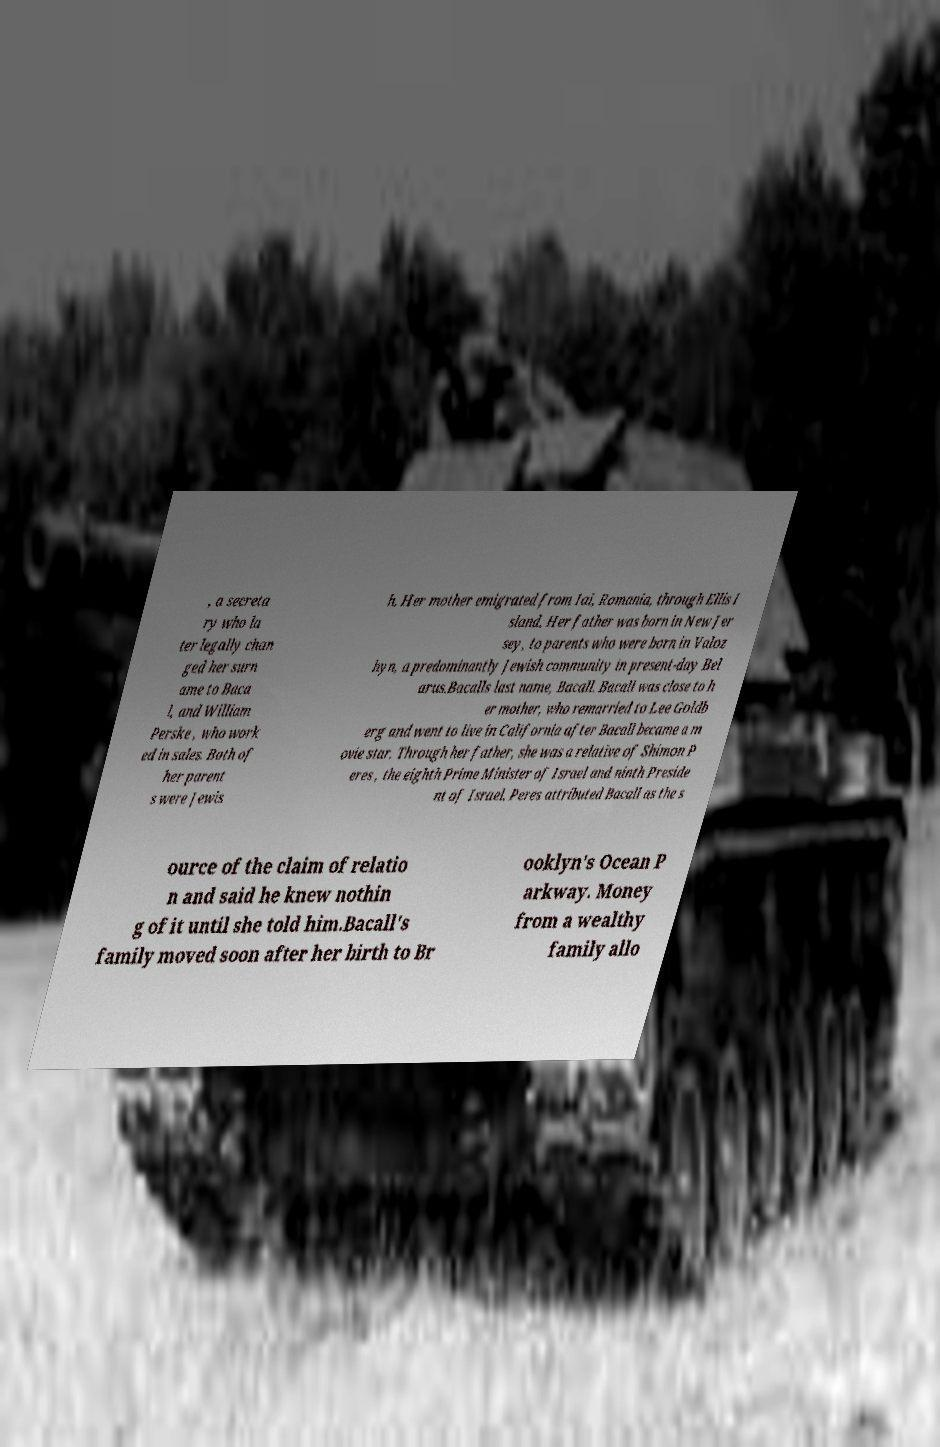Please identify and transcribe the text found in this image. , a secreta ry who la ter legally chan ged her surn ame to Baca l, and William Perske , who work ed in sales. Both of her parent s were Jewis h. Her mother emigrated from Iai, Romania, through Ellis I sland. Her father was born in New Jer sey, to parents who were born in Valoz hyn, a predominantly Jewish community in present-day Bel arus.Bacalls last name, Bacall. Bacall was close to h er mother, who remarried to Lee Goldb erg and went to live in California after Bacall became a m ovie star. Through her father, she was a relative of Shimon P eres , the eighth Prime Minister of Israel and ninth Preside nt of Israel. Peres attributed Bacall as the s ource of the claim of relatio n and said he knew nothin g of it until she told him.Bacall's family moved soon after her birth to Br ooklyn's Ocean P arkway. Money from a wealthy family allo 